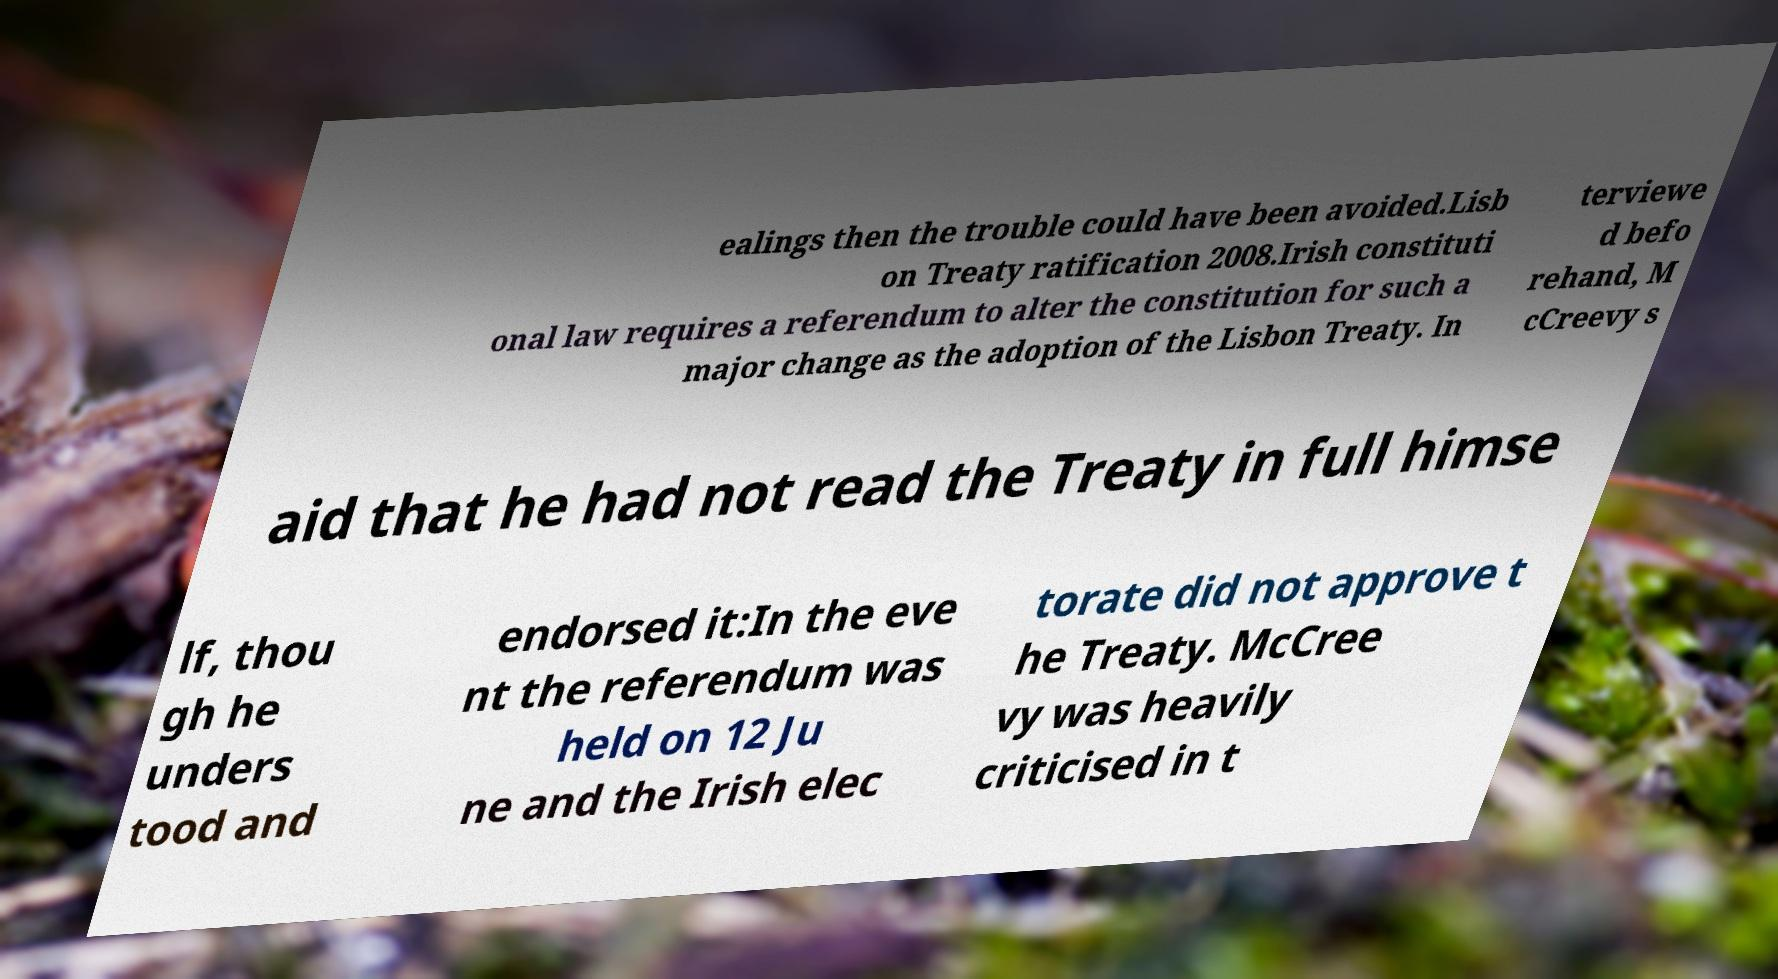Could you extract and type out the text from this image? ealings then the trouble could have been avoided.Lisb on Treaty ratification 2008.Irish constituti onal law requires a referendum to alter the constitution for such a major change as the adoption of the Lisbon Treaty. In terviewe d befo rehand, M cCreevy s aid that he had not read the Treaty in full himse lf, thou gh he unders tood and endorsed it:In the eve nt the referendum was held on 12 Ju ne and the Irish elec torate did not approve t he Treaty. McCree vy was heavily criticised in t 